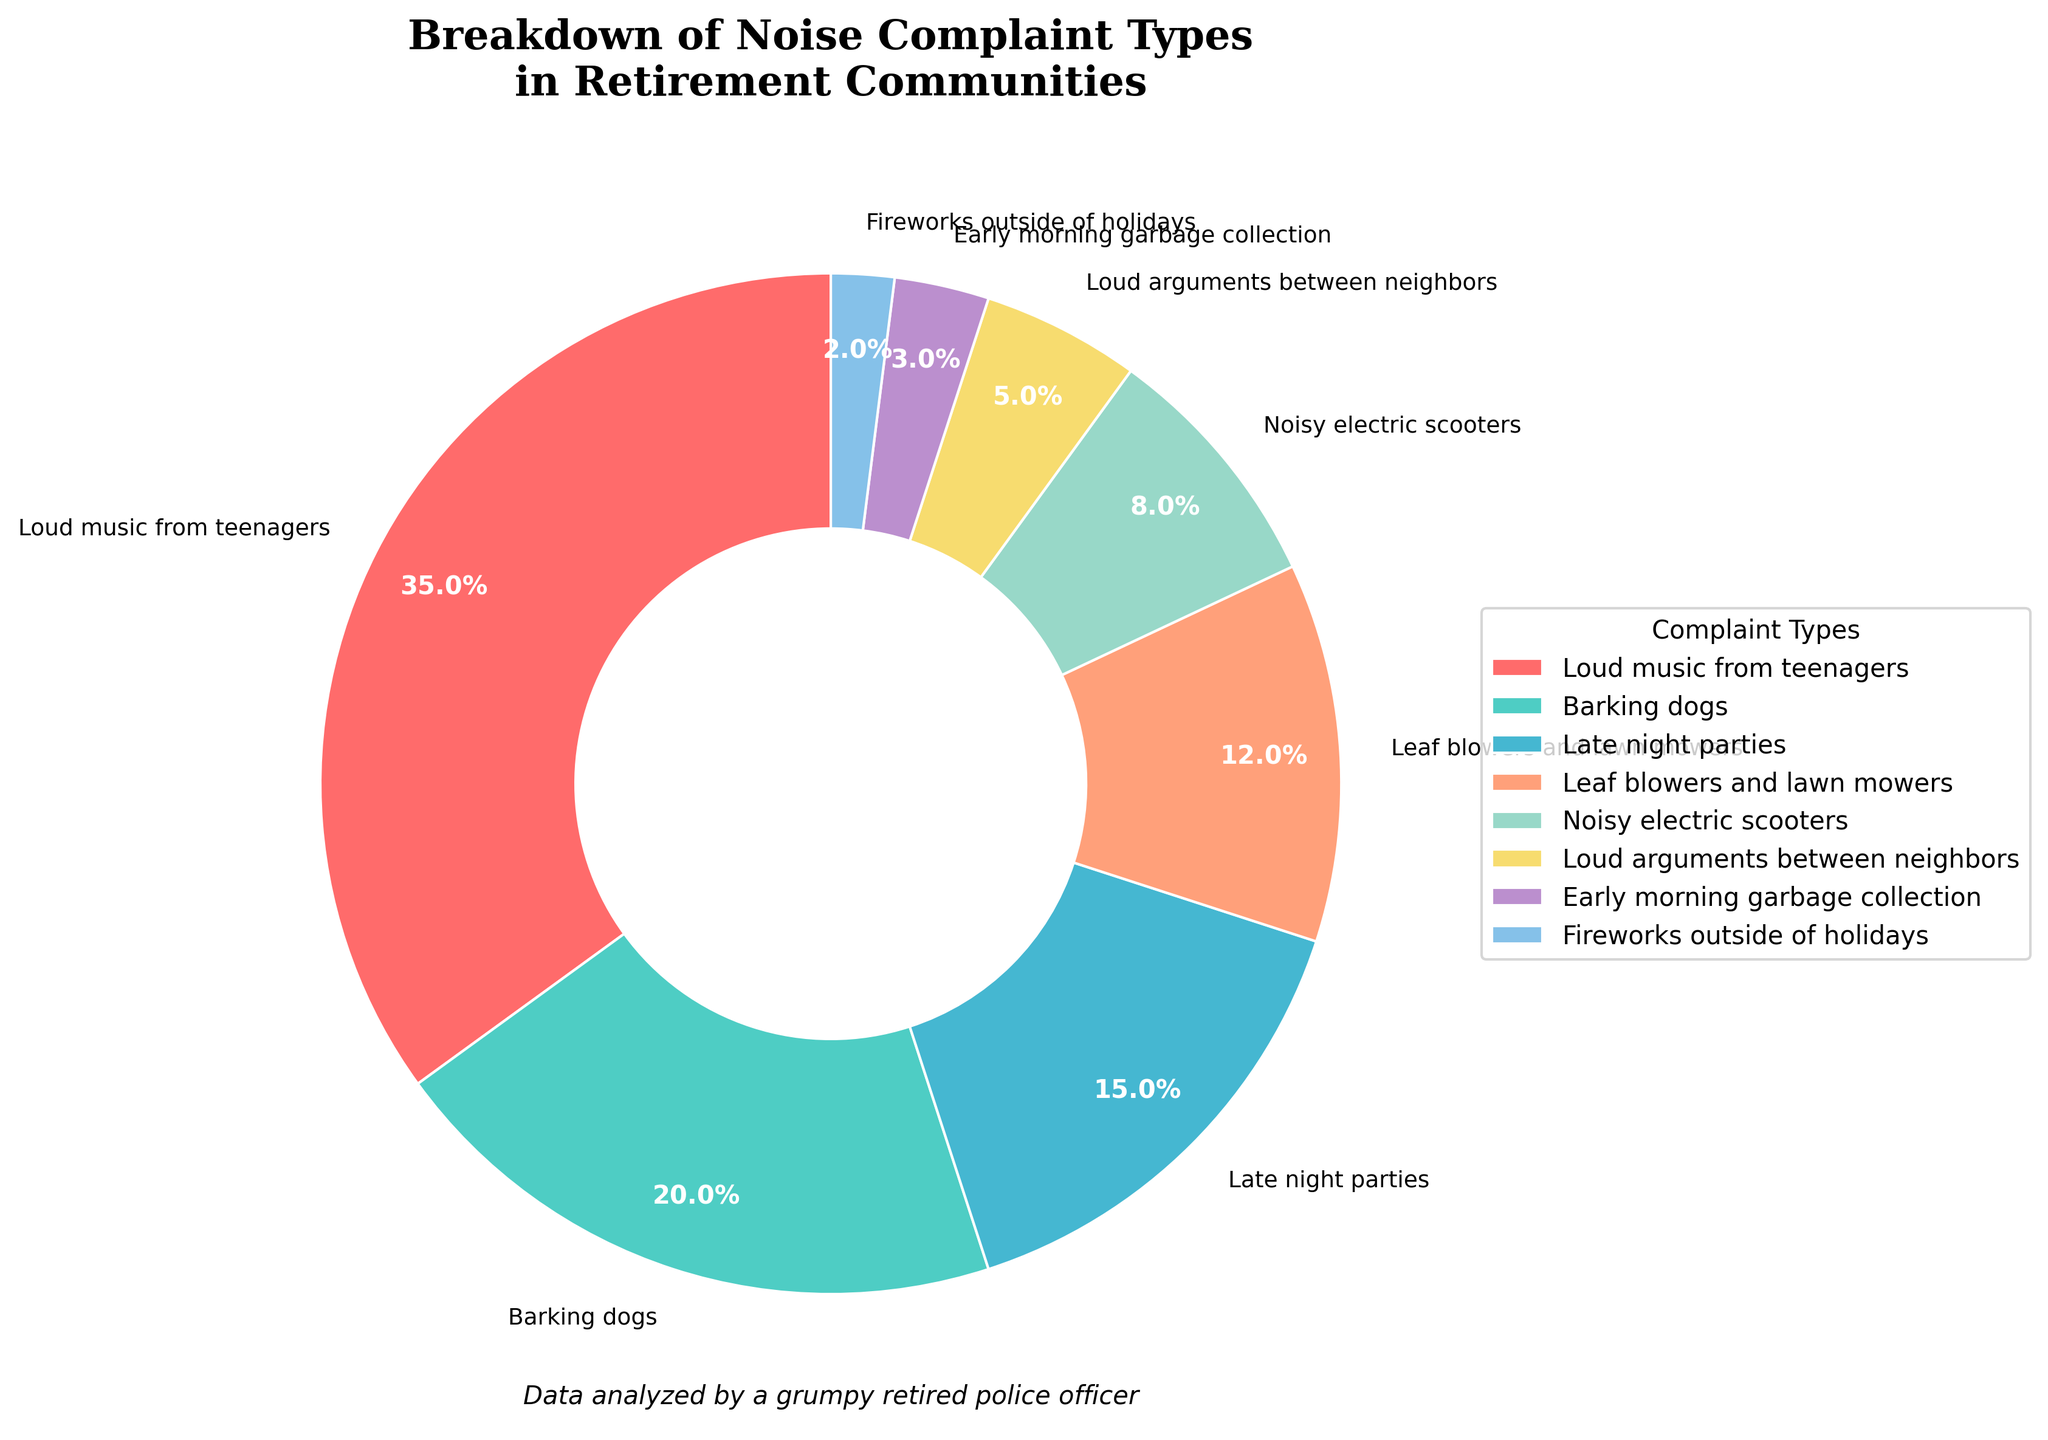Which complaint type has the highest percentage of noise complaints? The label for the largest segment of the pie chart says "Loud music from teenagers" with a percentage of 35%.
Answer: Loud music from teenagers Which two complaint types together make up half of the noise complaints? To find this, we add the percentages of different complaint types until we reach 50%. "Loud music from teenagers" (35%) and "Barking dogs" (20%) together make up 55%. Removing "Barking dogs," "Loud music from teenagers" (35%) and "Late night parties" (15%) together make 50%. Therefore, the closest to half is "Loud music from teenagers" and "Late night parties."
Answer: Loud music from teenagers and Late night parties What is the difference in the percentage of complaints between 'Loud music from teenagers' and 'Barking dogs'? Subtract the percentage of 'Barking dogs' (20%) from 'Loud music from teenagers' (35%). 35% - 20% = 15%.
Answer: 15% Which complaint type has the smallest percentage, and what is that percentage? On the pie chart, the slice labeled "Fireworks outside of holidays" is the smallest, and its percentage is 2%.
Answer: Fireworks outside of holidays, 2% What is the total percentage of complaints involving noise from animals? Identify and add the percentages of complaints involving animals: "Barking dogs" (20%) and no other categories involving animals. The total is 20%.
Answer: 20% Compare the total percentage of 'Loud arguments between neighbors' and 'Early morning garbage collection' against 'Late night parties'. Which is higher? Add the percentages for 'Loud arguments between neighbors' (5%) and 'Early morning garbage collection' (3%). 5% + 3% = 8%. 'Late night parties' is 15%. Since 8% is less than 15%, 'Late night parties' is higher.
Answer: Late night parties How much more do complaints about 'Loud music from teenagers' contribute to the total than 'Noisy electric scooters'? Subtract the percentage of 'Noisy electric scooters' (8%) from 'Loud music from teenagers' (35%). 35% - 8% = 27%.
Answer: 27% What percentage of complaints are made up by 'Leaf blowers and lawn mowers', 'Noisy electric scooters', and 'Early morning garbage collection' combined? Add the percentages for 'Leaf blowers and lawn mowers' (12%), 'Noisy electric scooters' (8%), and 'Early morning garbage collection' (3%). 12% + 8% + 3% = 23%.
Answer: 23% Which type of complaint is represented by a red color? The chart has distinct colors for each segment, and 'Loud music from teenagers' is labeled with a red segment.
Answer: Loud music from teenagers 